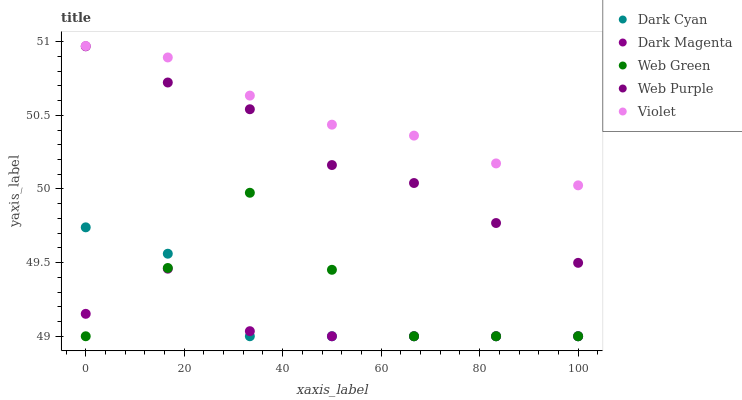Does Dark Magenta have the minimum area under the curve?
Answer yes or no. Yes. Does Violet have the maximum area under the curve?
Answer yes or no. Yes. Does Web Purple have the minimum area under the curve?
Answer yes or no. No. Does Web Purple have the maximum area under the curve?
Answer yes or no. No. Is Violet the smoothest?
Answer yes or no. Yes. Is Web Green the roughest?
Answer yes or no. Yes. Is Web Purple the smoothest?
Answer yes or no. No. Is Web Purple the roughest?
Answer yes or no. No. Does Dark Cyan have the lowest value?
Answer yes or no. Yes. Does Web Purple have the lowest value?
Answer yes or no. No. Does Violet have the highest value?
Answer yes or no. Yes. Does Web Purple have the highest value?
Answer yes or no. No. Is Web Green less than Web Purple?
Answer yes or no. Yes. Is Web Purple greater than Dark Magenta?
Answer yes or no. Yes. Does Dark Cyan intersect Web Green?
Answer yes or no. Yes. Is Dark Cyan less than Web Green?
Answer yes or no. No. Is Dark Cyan greater than Web Green?
Answer yes or no. No. Does Web Green intersect Web Purple?
Answer yes or no. No. 